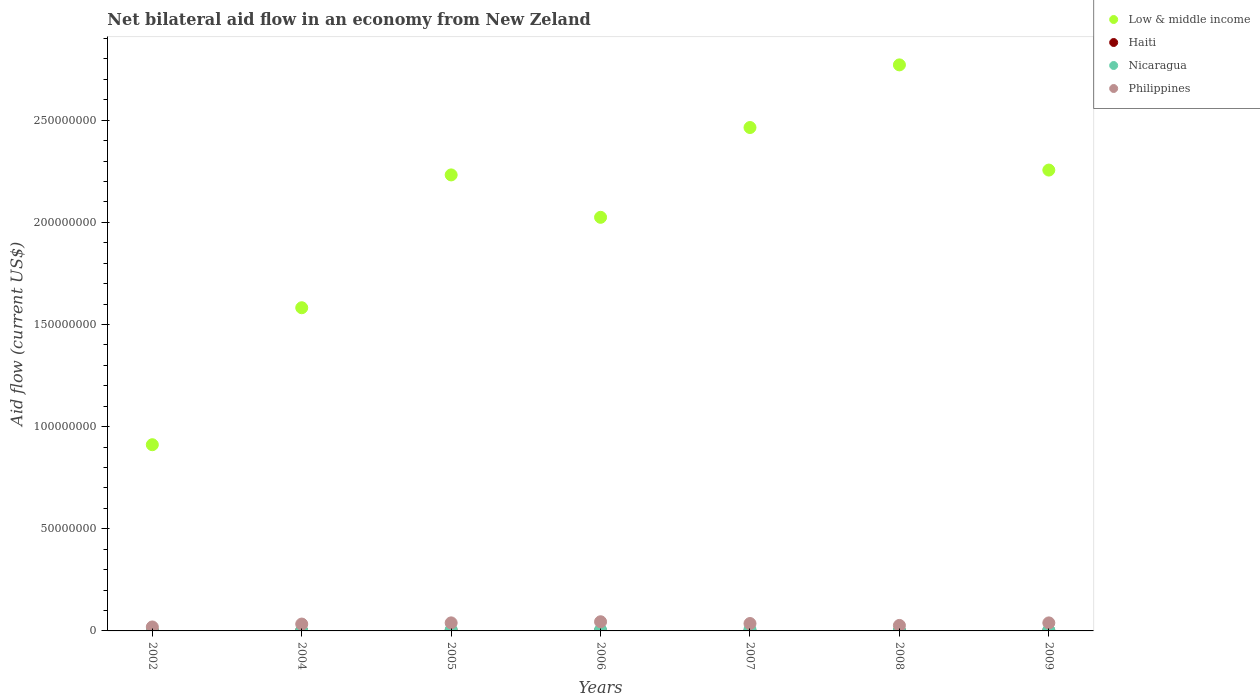Is the number of dotlines equal to the number of legend labels?
Ensure brevity in your answer.  Yes. What is the net bilateral aid flow in Philippines in 2007?
Offer a very short reply. 3.62e+06. Across all years, what is the minimum net bilateral aid flow in Low & middle income?
Give a very brief answer. 9.12e+07. What is the total net bilateral aid flow in Low & middle income in the graph?
Provide a short and direct response. 1.42e+09. What is the difference between the net bilateral aid flow in Haiti in 2004 and that in 2007?
Your response must be concise. 5.00e+04. What is the difference between the net bilateral aid flow in Nicaragua in 2004 and the net bilateral aid flow in Haiti in 2009?
Offer a terse response. 1.10e+05. What is the average net bilateral aid flow in Haiti per year?
Keep it short and to the point. 6.00e+04. In the year 2005, what is the difference between the net bilateral aid flow in Nicaragua and net bilateral aid flow in Low & middle income?
Ensure brevity in your answer.  -2.23e+08. In how many years, is the net bilateral aid flow in Haiti greater than 180000000 US$?
Your answer should be very brief. 0. What is the ratio of the net bilateral aid flow in Nicaragua in 2004 to that in 2007?
Give a very brief answer. 0.24. Is the net bilateral aid flow in Philippines in 2002 less than that in 2008?
Give a very brief answer. Yes. What is the difference between the highest and the second highest net bilateral aid flow in Philippines?
Your answer should be very brief. 5.50e+05. Is the sum of the net bilateral aid flow in Low & middle income in 2005 and 2007 greater than the maximum net bilateral aid flow in Philippines across all years?
Offer a terse response. Yes. Is it the case that in every year, the sum of the net bilateral aid flow in Low & middle income and net bilateral aid flow in Nicaragua  is greater than the sum of net bilateral aid flow in Haiti and net bilateral aid flow in Philippines?
Ensure brevity in your answer.  No. How many dotlines are there?
Your answer should be compact. 4. How many years are there in the graph?
Your answer should be compact. 7. What is the title of the graph?
Make the answer very short. Net bilateral aid flow in an economy from New Zeland. What is the Aid flow (current US$) in Low & middle income in 2002?
Provide a succinct answer. 9.12e+07. What is the Aid flow (current US$) of Philippines in 2002?
Your answer should be very brief. 1.94e+06. What is the Aid flow (current US$) of Low & middle income in 2004?
Provide a short and direct response. 1.58e+08. What is the Aid flow (current US$) of Haiti in 2004?
Your response must be concise. 7.00e+04. What is the Aid flow (current US$) in Philippines in 2004?
Offer a very short reply. 3.36e+06. What is the Aid flow (current US$) of Low & middle income in 2005?
Make the answer very short. 2.23e+08. What is the Aid flow (current US$) in Haiti in 2005?
Offer a terse response. 1.30e+05. What is the Aid flow (current US$) in Nicaragua in 2005?
Give a very brief answer. 5.80e+05. What is the Aid flow (current US$) of Philippines in 2005?
Give a very brief answer. 3.94e+06. What is the Aid flow (current US$) in Low & middle income in 2006?
Offer a very short reply. 2.02e+08. What is the Aid flow (current US$) of Haiti in 2006?
Provide a short and direct response. 7.00e+04. What is the Aid flow (current US$) in Nicaragua in 2006?
Offer a very short reply. 5.00e+05. What is the Aid flow (current US$) of Philippines in 2006?
Offer a very short reply. 4.49e+06. What is the Aid flow (current US$) of Low & middle income in 2007?
Provide a short and direct response. 2.46e+08. What is the Aid flow (current US$) of Haiti in 2007?
Keep it short and to the point. 2.00e+04. What is the Aid flow (current US$) in Philippines in 2007?
Offer a terse response. 3.62e+06. What is the Aid flow (current US$) in Low & middle income in 2008?
Provide a succinct answer. 2.77e+08. What is the Aid flow (current US$) in Haiti in 2008?
Provide a succinct answer. 6.00e+04. What is the Aid flow (current US$) in Nicaragua in 2008?
Offer a very short reply. 3.20e+05. What is the Aid flow (current US$) in Philippines in 2008?
Your answer should be very brief. 2.69e+06. What is the Aid flow (current US$) in Low & middle income in 2009?
Offer a terse response. 2.26e+08. What is the Aid flow (current US$) in Nicaragua in 2009?
Keep it short and to the point. 4.00e+05. What is the Aid flow (current US$) of Philippines in 2009?
Provide a short and direct response. 3.93e+06. Across all years, what is the maximum Aid flow (current US$) in Low & middle income?
Make the answer very short. 2.77e+08. Across all years, what is the maximum Aid flow (current US$) in Philippines?
Provide a succinct answer. 4.49e+06. Across all years, what is the minimum Aid flow (current US$) of Low & middle income?
Keep it short and to the point. 9.12e+07. Across all years, what is the minimum Aid flow (current US$) of Nicaragua?
Make the answer very short. 1.00e+05. Across all years, what is the minimum Aid flow (current US$) of Philippines?
Make the answer very short. 1.94e+06. What is the total Aid flow (current US$) in Low & middle income in the graph?
Provide a succinct answer. 1.42e+09. What is the total Aid flow (current US$) of Haiti in the graph?
Offer a terse response. 4.20e+05. What is the total Aid flow (current US$) of Nicaragua in the graph?
Your answer should be compact. 2.77e+06. What is the total Aid flow (current US$) in Philippines in the graph?
Keep it short and to the point. 2.40e+07. What is the difference between the Aid flow (current US$) in Low & middle income in 2002 and that in 2004?
Provide a short and direct response. -6.71e+07. What is the difference between the Aid flow (current US$) of Philippines in 2002 and that in 2004?
Offer a terse response. -1.42e+06. What is the difference between the Aid flow (current US$) in Low & middle income in 2002 and that in 2005?
Provide a succinct answer. -1.32e+08. What is the difference between the Aid flow (current US$) of Nicaragua in 2002 and that in 2005?
Your response must be concise. -4.80e+05. What is the difference between the Aid flow (current US$) in Low & middle income in 2002 and that in 2006?
Provide a succinct answer. -1.11e+08. What is the difference between the Aid flow (current US$) in Haiti in 2002 and that in 2006?
Offer a terse response. -6.00e+04. What is the difference between the Aid flow (current US$) in Nicaragua in 2002 and that in 2006?
Your response must be concise. -4.00e+05. What is the difference between the Aid flow (current US$) in Philippines in 2002 and that in 2006?
Make the answer very short. -2.55e+06. What is the difference between the Aid flow (current US$) in Low & middle income in 2002 and that in 2007?
Offer a very short reply. -1.55e+08. What is the difference between the Aid flow (current US$) of Haiti in 2002 and that in 2007?
Offer a very short reply. -10000. What is the difference between the Aid flow (current US$) in Nicaragua in 2002 and that in 2007?
Provide a succinct answer. -6.00e+05. What is the difference between the Aid flow (current US$) of Philippines in 2002 and that in 2007?
Give a very brief answer. -1.68e+06. What is the difference between the Aid flow (current US$) in Low & middle income in 2002 and that in 2008?
Make the answer very short. -1.86e+08. What is the difference between the Aid flow (current US$) of Nicaragua in 2002 and that in 2008?
Make the answer very short. -2.20e+05. What is the difference between the Aid flow (current US$) of Philippines in 2002 and that in 2008?
Your answer should be compact. -7.50e+05. What is the difference between the Aid flow (current US$) of Low & middle income in 2002 and that in 2009?
Ensure brevity in your answer.  -1.34e+08. What is the difference between the Aid flow (current US$) of Haiti in 2002 and that in 2009?
Your answer should be very brief. -5.00e+04. What is the difference between the Aid flow (current US$) of Philippines in 2002 and that in 2009?
Offer a very short reply. -1.99e+06. What is the difference between the Aid flow (current US$) in Low & middle income in 2004 and that in 2005?
Provide a short and direct response. -6.50e+07. What is the difference between the Aid flow (current US$) in Haiti in 2004 and that in 2005?
Your answer should be compact. -6.00e+04. What is the difference between the Aid flow (current US$) in Nicaragua in 2004 and that in 2005?
Provide a succinct answer. -4.10e+05. What is the difference between the Aid flow (current US$) in Philippines in 2004 and that in 2005?
Offer a terse response. -5.80e+05. What is the difference between the Aid flow (current US$) of Low & middle income in 2004 and that in 2006?
Give a very brief answer. -4.43e+07. What is the difference between the Aid flow (current US$) of Nicaragua in 2004 and that in 2006?
Offer a very short reply. -3.30e+05. What is the difference between the Aid flow (current US$) in Philippines in 2004 and that in 2006?
Provide a succinct answer. -1.13e+06. What is the difference between the Aid flow (current US$) of Low & middle income in 2004 and that in 2007?
Make the answer very short. -8.82e+07. What is the difference between the Aid flow (current US$) of Nicaragua in 2004 and that in 2007?
Make the answer very short. -5.30e+05. What is the difference between the Aid flow (current US$) of Low & middle income in 2004 and that in 2008?
Provide a succinct answer. -1.19e+08. What is the difference between the Aid flow (current US$) in Haiti in 2004 and that in 2008?
Your answer should be compact. 10000. What is the difference between the Aid flow (current US$) of Philippines in 2004 and that in 2008?
Provide a succinct answer. 6.70e+05. What is the difference between the Aid flow (current US$) of Low & middle income in 2004 and that in 2009?
Provide a succinct answer. -6.74e+07. What is the difference between the Aid flow (current US$) of Nicaragua in 2004 and that in 2009?
Make the answer very short. -2.30e+05. What is the difference between the Aid flow (current US$) of Philippines in 2004 and that in 2009?
Give a very brief answer. -5.70e+05. What is the difference between the Aid flow (current US$) in Low & middle income in 2005 and that in 2006?
Provide a short and direct response. 2.08e+07. What is the difference between the Aid flow (current US$) of Haiti in 2005 and that in 2006?
Make the answer very short. 6.00e+04. What is the difference between the Aid flow (current US$) in Philippines in 2005 and that in 2006?
Keep it short and to the point. -5.50e+05. What is the difference between the Aid flow (current US$) in Low & middle income in 2005 and that in 2007?
Your answer should be compact. -2.32e+07. What is the difference between the Aid flow (current US$) of Haiti in 2005 and that in 2007?
Your answer should be compact. 1.10e+05. What is the difference between the Aid flow (current US$) in Low & middle income in 2005 and that in 2008?
Ensure brevity in your answer.  -5.39e+07. What is the difference between the Aid flow (current US$) of Haiti in 2005 and that in 2008?
Provide a succinct answer. 7.00e+04. What is the difference between the Aid flow (current US$) in Philippines in 2005 and that in 2008?
Ensure brevity in your answer.  1.25e+06. What is the difference between the Aid flow (current US$) of Low & middle income in 2005 and that in 2009?
Provide a succinct answer. -2.37e+06. What is the difference between the Aid flow (current US$) in Nicaragua in 2005 and that in 2009?
Keep it short and to the point. 1.80e+05. What is the difference between the Aid flow (current US$) in Low & middle income in 2006 and that in 2007?
Provide a succinct answer. -4.40e+07. What is the difference between the Aid flow (current US$) of Haiti in 2006 and that in 2007?
Provide a succinct answer. 5.00e+04. What is the difference between the Aid flow (current US$) in Philippines in 2006 and that in 2007?
Provide a succinct answer. 8.70e+05. What is the difference between the Aid flow (current US$) in Low & middle income in 2006 and that in 2008?
Keep it short and to the point. -7.46e+07. What is the difference between the Aid flow (current US$) of Nicaragua in 2006 and that in 2008?
Ensure brevity in your answer.  1.80e+05. What is the difference between the Aid flow (current US$) in Philippines in 2006 and that in 2008?
Your answer should be very brief. 1.80e+06. What is the difference between the Aid flow (current US$) in Low & middle income in 2006 and that in 2009?
Make the answer very short. -2.31e+07. What is the difference between the Aid flow (current US$) of Haiti in 2006 and that in 2009?
Your answer should be compact. 10000. What is the difference between the Aid flow (current US$) in Philippines in 2006 and that in 2009?
Make the answer very short. 5.60e+05. What is the difference between the Aid flow (current US$) in Low & middle income in 2007 and that in 2008?
Ensure brevity in your answer.  -3.07e+07. What is the difference between the Aid flow (current US$) of Haiti in 2007 and that in 2008?
Make the answer very short. -4.00e+04. What is the difference between the Aid flow (current US$) of Philippines in 2007 and that in 2008?
Offer a terse response. 9.30e+05. What is the difference between the Aid flow (current US$) of Low & middle income in 2007 and that in 2009?
Make the answer very short. 2.08e+07. What is the difference between the Aid flow (current US$) in Philippines in 2007 and that in 2009?
Your answer should be compact. -3.10e+05. What is the difference between the Aid flow (current US$) in Low & middle income in 2008 and that in 2009?
Offer a terse response. 5.15e+07. What is the difference between the Aid flow (current US$) of Nicaragua in 2008 and that in 2009?
Offer a terse response. -8.00e+04. What is the difference between the Aid flow (current US$) of Philippines in 2008 and that in 2009?
Provide a succinct answer. -1.24e+06. What is the difference between the Aid flow (current US$) of Low & middle income in 2002 and the Aid flow (current US$) of Haiti in 2004?
Give a very brief answer. 9.11e+07. What is the difference between the Aid flow (current US$) in Low & middle income in 2002 and the Aid flow (current US$) in Nicaragua in 2004?
Offer a very short reply. 9.10e+07. What is the difference between the Aid flow (current US$) in Low & middle income in 2002 and the Aid flow (current US$) in Philippines in 2004?
Ensure brevity in your answer.  8.78e+07. What is the difference between the Aid flow (current US$) of Haiti in 2002 and the Aid flow (current US$) of Nicaragua in 2004?
Your response must be concise. -1.60e+05. What is the difference between the Aid flow (current US$) in Haiti in 2002 and the Aid flow (current US$) in Philippines in 2004?
Keep it short and to the point. -3.35e+06. What is the difference between the Aid flow (current US$) in Nicaragua in 2002 and the Aid flow (current US$) in Philippines in 2004?
Give a very brief answer. -3.26e+06. What is the difference between the Aid flow (current US$) in Low & middle income in 2002 and the Aid flow (current US$) in Haiti in 2005?
Provide a succinct answer. 9.10e+07. What is the difference between the Aid flow (current US$) in Low & middle income in 2002 and the Aid flow (current US$) in Nicaragua in 2005?
Offer a very short reply. 9.06e+07. What is the difference between the Aid flow (current US$) in Low & middle income in 2002 and the Aid flow (current US$) in Philippines in 2005?
Provide a succinct answer. 8.72e+07. What is the difference between the Aid flow (current US$) of Haiti in 2002 and the Aid flow (current US$) of Nicaragua in 2005?
Offer a very short reply. -5.70e+05. What is the difference between the Aid flow (current US$) of Haiti in 2002 and the Aid flow (current US$) of Philippines in 2005?
Make the answer very short. -3.93e+06. What is the difference between the Aid flow (current US$) in Nicaragua in 2002 and the Aid flow (current US$) in Philippines in 2005?
Ensure brevity in your answer.  -3.84e+06. What is the difference between the Aid flow (current US$) in Low & middle income in 2002 and the Aid flow (current US$) in Haiti in 2006?
Your answer should be compact. 9.11e+07. What is the difference between the Aid flow (current US$) of Low & middle income in 2002 and the Aid flow (current US$) of Nicaragua in 2006?
Give a very brief answer. 9.07e+07. What is the difference between the Aid flow (current US$) of Low & middle income in 2002 and the Aid flow (current US$) of Philippines in 2006?
Your answer should be compact. 8.67e+07. What is the difference between the Aid flow (current US$) in Haiti in 2002 and the Aid flow (current US$) in Nicaragua in 2006?
Your response must be concise. -4.90e+05. What is the difference between the Aid flow (current US$) of Haiti in 2002 and the Aid flow (current US$) of Philippines in 2006?
Offer a very short reply. -4.48e+06. What is the difference between the Aid flow (current US$) of Nicaragua in 2002 and the Aid flow (current US$) of Philippines in 2006?
Make the answer very short. -4.39e+06. What is the difference between the Aid flow (current US$) in Low & middle income in 2002 and the Aid flow (current US$) in Haiti in 2007?
Ensure brevity in your answer.  9.11e+07. What is the difference between the Aid flow (current US$) in Low & middle income in 2002 and the Aid flow (current US$) in Nicaragua in 2007?
Offer a terse response. 9.05e+07. What is the difference between the Aid flow (current US$) in Low & middle income in 2002 and the Aid flow (current US$) in Philippines in 2007?
Give a very brief answer. 8.75e+07. What is the difference between the Aid flow (current US$) in Haiti in 2002 and the Aid flow (current US$) in Nicaragua in 2007?
Your response must be concise. -6.90e+05. What is the difference between the Aid flow (current US$) of Haiti in 2002 and the Aid flow (current US$) of Philippines in 2007?
Offer a terse response. -3.61e+06. What is the difference between the Aid flow (current US$) of Nicaragua in 2002 and the Aid flow (current US$) of Philippines in 2007?
Provide a succinct answer. -3.52e+06. What is the difference between the Aid flow (current US$) in Low & middle income in 2002 and the Aid flow (current US$) in Haiti in 2008?
Give a very brief answer. 9.11e+07. What is the difference between the Aid flow (current US$) in Low & middle income in 2002 and the Aid flow (current US$) in Nicaragua in 2008?
Ensure brevity in your answer.  9.08e+07. What is the difference between the Aid flow (current US$) of Low & middle income in 2002 and the Aid flow (current US$) of Philippines in 2008?
Your answer should be compact. 8.85e+07. What is the difference between the Aid flow (current US$) of Haiti in 2002 and the Aid flow (current US$) of Nicaragua in 2008?
Your response must be concise. -3.10e+05. What is the difference between the Aid flow (current US$) in Haiti in 2002 and the Aid flow (current US$) in Philippines in 2008?
Ensure brevity in your answer.  -2.68e+06. What is the difference between the Aid flow (current US$) in Nicaragua in 2002 and the Aid flow (current US$) in Philippines in 2008?
Your answer should be compact. -2.59e+06. What is the difference between the Aid flow (current US$) in Low & middle income in 2002 and the Aid flow (current US$) in Haiti in 2009?
Make the answer very short. 9.11e+07. What is the difference between the Aid flow (current US$) in Low & middle income in 2002 and the Aid flow (current US$) in Nicaragua in 2009?
Your response must be concise. 9.08e+07. What is the difference between the Aid flow (current US$) of Low & middle income in 2002 and the Aid flow (current US$) of Philippines in 2009?
Offer a very short reply. 8.72e+07. What is the difference between the Aid flow (current US$) of Haiti in 2002 and the Aid flow (current US$) of Nicaragua in 2009?
Your answer should be compact. -3.90e+05. What is the difference between the Aid flow (current US$) of Haiti in 2002 and the Aid flow (current US$) of Philippines in 2009?
Offer a very short reply. -3.92e+06. What is the difference between the Aid flow (current US$) in Nicaragua in 2002 and the Aid flow (current US$) in Philippines in 2009?
Provide a short and direct response. -3.83e+06. What is the difference between the Aid flow (current US$) in Low & middle income in 2004 and the Aid flow (current US$) in Haiti in 2005?
Keep it short and to the point. 1.58e+08. What is the difference between the Aid flow (current US$) of Low & middle income in 2004 and the Aid flow (current US$) of Nicaragua in 2005?
Ensure brevity in your answer.  1.58e+08. What is the difference between the Aid flow (current US$) of Low & middle income in 2004 and the Aid flow (current US$) of Philippines in 2005?
Offer a very short reply. 1.54e+08. What is the difference between the Aid flow (current US$) of Haiti in 2004 and the Aid flow (current US$) of Nicaragua in 2005?
Your response must be concise. -5.10e+05. What is the difference between the Aid flow (current US$) in Haiti in 2004 and the Aid flow (current US$) in Philippines in 2005?
Your answer should be compact. -3.87e+06. What is the difference between the Aid flow (current US$) of Nicaragua in 2004 and the Aid flow (current US$) of Philippines in 2005?
Make the answer very short. -3.77e+06. What is the difference between the Aid flow (current US$) of Low & middle income in 2004 and the Aid flow (current US$) of Haiti in 2006?
Make the answer very short. 1.58e+08. What is the difference between the Aid flow (current US$) of Low & middle income in 2004 and the Aid flow (current US$) of Nicaragua in 2006?
Ensure brevity in your answer.  1.58e+08. What is the difference between the Aid flow (current US$) of Low & middle income in 2004 and the Aid flow (current US$) of Philippines in 2006?
Your response must be concise. 1.54e+08. What is the difference between the Aid flow (current US$) in Haiti in 2004 and the Aid flow (current US$) in Nicaragua in 2006?
Keep it short and to the point. -4.30e+05. What is the difference between the Aid flow (current US$) in Haiti in 2004 and the Aid flow (current US$) in Philippines in 2006?
Offer a terse response. -4.42e+06. What is the difference between the Aid flow (current US$) in Nicaragua in 2004 and the Aid flow (current US$) in Philippines in 2006?
Make the answer very short. -4.32e+06. What is the difference between the Aid flow (current US$) in Low & middle income in 2004 and the Aid flow (current US$) in Haiti in 2007?
Your response must be concise. 1.58e+08. What is the difference between the Aid flow (current US$) in Low & middle income in 2004 and the Aid flow (current US$) in Nicaragua in 2007?
Provide a succinct answer. 1.58e+08. What is the difference between the Aid flow (current US$) in Low & middle income in 2004 and the Aid flow (current US$) in Philippines in 2007?
Provide a succinct answer. 1.55e+08. What is the difference between the Aid flow (current US$) in Haiti in 2004 and the Aid flow (current US$) in Nicaragua in 2007?
Offer a terse response. -6.30e+05. What is the difference between the Aid flow (current US$) of Haiti in 2004 and the Aid flow (current US$) of Philippines in 2007?
Keep it short and to the point. -3.55e+06. What is the difference between the Aid flow (current US$) of Nicaragua in 2004 and the Aid flow (current US$) of Philippines in 2007?
Keep it short and to the point. -3.45e+06. What is the difference between the Aid flow (current US$) of Low & middle income in 2004 and the Aid flow (current US$) of Haiti in 2008?
Offer a terse response. 1.58e+08. What is the difference between the Aid flow (current US$) in Low & middle income in 2004 and the Aid flow (current US$) in Nicaragua in 2008?
Keep it short and to the point. 1.58e+08. What is the difference between the Aid flow (current US$) of Low & middle income in 2004 and the Aid flow (current US$) of Philippines in 2008?
Give a very brief answer. 1.56e+08. What is the difference between the Aid flow (current US$) of Haiti in 2004 and the Aid flow (current US$) of Nicaragua in 2008?
Your answer should be very brief. -2.50e+05. What is the difference between the Aid flow (current US$) of Haiti in 2004 and the Aid flow (current US$) of Philippines in 2008?
Your answer should be compact. -2.62e+06. What is the difference between the Aid flow (current US$) of Nicaragua in 2004 and the Aid flow (current US$) of Philippines in 2008?
Your answer should be very brief. -2.52e+06. What is the difference between the Aid flow (current US$) in Low & middle income in 2004 and the Aid flow (current US$) in Haiti in 2009?
Your response must be concise. 1.58e+08. What is the difference between the Aid flow (current US$) of Low & middle income in 2004 and the Aid flow (current US$) of Nicaragua in 2009?
Provide a short and direct response. 1.58e+08. What is the difference between the Aid flow (current US$) in Low & middle income in 2004 and the Aid flow (current US$) in Philippines in 2009?
Keep it short and to the point. 1.54e+08. What is the difference between the Aid flow (current US$) of Haiti in 2004 and the Aid flow (current US$) of Nicaragua in 2009?
Make the answer very short. -3.30e+05. What is the difference between the Aid flow (current US$) in Haiti in 2004 and the Aid flow (current US$) in Philippines in 2009?
Give a very brief answer. -3.86e+06. What is the difference between the Aid flow (current US$) in Nicaragua in 2004 and the Aid flow (current US$) in Philippines in 2009?
Offer a very short reply. -3.76e+06. What is the difference between the Aid flow (current US$) in Low & middle income in 2005 and the Aid flow (current US$) in Haiti in 2006?
Provide a succinct answer. 2.23e+08. What is the difference between the Aid flow (current US$) in Low & middle income in 2005 and the Aid flow (current US$) in Nicaragua in 2006?
Make the answer very short. 2.23e+08. What is the difference between the Aid flow (current US$) of Low & middle income in 2005 and the Aid flow (current US$) of Philippines in 2006?
Keep it short and to the point. 2.19e+08. What is the difference between the Aid flow (current US$) of Haiti in 2005 and the Aid flow (current US$) of Nicaragua in 2006?
Provide a succinct answer. -3.70e+05. What is the difference between the Aid flow (current US$) of Haiti in 2005 and the Aid flow (current US$) of Philippines in 2006?
Make the answer very short. -4.36e+06. What is the difference between the Aid flow (current US$) in Nicaragua in 2005 and the Aid flow (current US$) in Philippines in 2006?
Give a very brief answer. -3.91e+06. What is the difference between the Aid flow (current US$) in Low & middle income in 2005 and the Aid flow (current US$) in Haiti in 2007?
Offer a terse response. 2.23e+08. What is the difference between the Aid flow (current US$) in Low & middle income in 2005 and the Aid flow (current US$) in Nicaragua in 2007?
Keep it short and to the point. 2.23e+08. What is the difference between the Aid flow (current US$) in Low & middle income in 2005 and the Aid flow (current US$) in Philippines in 2007?
Your answer should be very brief. 2.20e+08. What is the difference between the Aid flow (current US$) in Haiti in 2005 and the Aid flow (current US$) in Nicaragua in 2007?
Your answer should be very brief. -5.70e+05. What is the difference between the Aid flow (current US$) of Haiti in 2005 and the Aid flow (current US$) of Philippines in 2007?
Provide a short and direct response. -3.49e+06. What is the difference between the Aid flow (current US$) of Nicaragua in 2005 and the Aid flow (current US$) of Philippines in 2007?
Keep it short and to the point. -3.04e+06. What is the difference between the Aid flow (current US$) of Low & middle income in 2005 and the Aid flow (current US$) of Haiti in 2008?
Ensure brevity in your answer.  2.23e+08. What is the difference between the Aid flow (current US$) of Low & middle income in 2005 and the Aid flow (current US$) of Nicaragua in 2008?
Ensure brevity in your answer.  2.23e+08. What is the difference between the Aid flow (current US$) in Low & middle income in 2005 and the Aid flow (current US$) in Philippines in 2008?
Offer a terse response. 2.21e+08. What is the difference between the Aid flow (current US$) of Haiti in 2005 and the Aid flow (current US$) of Nicaragua in 2008?
Give a very brief answer. -1.90e+05. What is the difference between the Aid flow (current US$) in Haiti in 2005 and the Aid flow (current US$) in Philippines in 2008?
Your answer should be compact. -2.56e+06. What is the difference between the Aid flow (current US$) in Nicaragua in 2005 and the Aid flow (current US$) in Philippines in 2008?
Provide a succinct answer. -2.11e+06. What is the difference between the Aid flow (current US$) in Low & middle income in 2005 and the Aid flow (current US$) in Haiti in 2009?
Offer a very short reply. 2.23e+08. What is the difference between the Aid flow (current US$) in Low & middle income in 2005 and the Aid flow (current US$) in Nicaragua in 2009?
Your response must be concise. 2.23e+08. What is the difference between the Aid flow (current US$) in Low & middle income in 2005 and the Aid flow (current US$) in Philippines in 2009?
Your response must be concise. 2.19e+08. What is the difference between the Aid flow (current US$) of Haiti in 2005 and the Aid flow (current US$) of Philippines in 2009?
Your answer should be compact. -3.80e+06. What is the difference between the Aid flow (current US$) of Nicaragua in 2005 and the Aid flow (current US$) of Philippines in 2009?
Your answer should be compact. -3.35e+06. What is the difference between the Aid flow (current US$) of Low & middle income in 2006 and the Aid flow (current US$) of Haiti in 2007?
Keep it short and to the point. 2.02e+08. What is the difference between the Aid flow (current US$) of Low & middle income in 2006 and the Aid flow (current US$) of Nicaragua in 2007?
Your answer should be very brief. 2.02e+08. What is the difference between the Aid flow (current US$) in Low & middle income in 2006 and the Aid flow (current US$) in Philippines in 2007?
Make the answer very short. 1.99e+08. What is the difference between the Aid flow (current US$) of Haiti in 2006 and the Aid flow (current US$) of Nicaragua in 2007?
Your answer should be very brief. -6.30e+05. What is the difference between the Aid flow (current US$) in Haiti in 2006 and the Aid flow (current US$) in Philippines in 2007?
Offer a terse response. -3.55e+06. What is the difference between the Aid flow (current US$) in Nicaragua in 2006 and the Aid flow (current US$) in Philippines in 2007?
Ensure brevity in your answer.  -3.12e+06. What is the difference between the Aid flow (current US$) of Low & middle income in 2006 and the Aid flow (current US$) of Haiti in 2008?
Keep it short and to the point. 2.02e+08. What is the difference between the Aid flow (current US$) in Low & middle income in 2006 and the Aid flow (current US$) in Nicaragua in 2008?
Your answer should be compact. 2.02e+08. What is the difference between the Aid flow (current US$) in Low & middle income in 2006 and the Aid flow (current US$) in Philippines in 2008?
Your response must be concise. 2.00e+08. What is the difference between the Aid flow (current US$) of Haiti in 2006 and the Aid flow (current US$) of Nicaragua in 2008?
Ensure brevity in your answer.  -2.50e+05. What is the difference between the Aid flow (current US$) of Haiti in 2006 and the Aid flow (current US$) of Philippines in 2008?
Give a very brief answer. -2.62e+06. What is the difference between the Aid flow (current US$) in Nicaragua in 2006 and the Aid flow (current US$) in Philippines in 2008?
Your answer should be compact. -2.19e+06. What is the difference between the Aid flow (current US$) in Low & middle income in 2006 and the Aid flow (current US$) in Haiti in 2009?
Your answer should be compact. 2.02e+08. What is the difference between the Aid flow (current US$) of Low & middle income in 2006 and the Aid flow (current US$) of Nicaragua in 2009?
Give a very brief answer. 2.02e+08. What is the difference between the Aid flow (current US$) in Low & middle income in 2006 and the Aid flow (current US$) in Philippines in 2009?
Give a very brief answer. 1.99e+08. What is the difference between the Aid flow (current US$) in Haiti in 2006 and the Aid flow (current US$) in Nicaragua in 2009?
Give a very brief answer. -3.30e+05. What is the difference between the Aid flow (current US$) of Haiti in 2006 and the Aid flow (current US$) of Philippines in 2009?
Your answer should be very brief. -3.86e+06. What is the difference between the Aid flow (current US$) of Nicaragua in 2006 and the Aid flow (current US$) of Philippines in 2009?
Provide a succinct answer. -3.43e+06. What is the difference between the Aid flow (current US$) in Low & middle income in 2007 and the Aid flow (current US$) in Haiti in 2008?
Offer a terse response. 2.46e+08. What is the difference between the Aid flow (current US$) in Low & middle income in 2007 and the Aid flow (current US$) in Nicaragua in 2008?
Your response must be concise. 2.46e+08. What is the difference between the Aid flow (current US$) in Low & middle income in 2007 and the Aid flow (current US$) in Philippines in 2008?
Ensure brevity in your answer.  2.44e+08. What is the difference between the Aid flow (current US$) of Haiti in 2007 and the Aid flow (current US$) of Nicaragua in 2008?
Give a very brief answer. -3.00e+05. What is the difference between the Aid flow (current US$) in Haiti in 2007 and the Aid flow (current US$) in Philippines in 2008?
Your answer should be very brief. -2.67e+06. What is the difference between the Aid flow (current US$) in Nicaragua in 2007 and the Aid flow (current US$) in Philippines in 2008?
Ensure brevity in your answer.  -1.99e+06. What is the difference between the Aid flow (current US$) in Low & middle income in 2007 and the Aid flow (current US$) in Haiti in 2009?
Your answer should be very brief. 2.46e+08. What is the difference between the Aid flow (current US$) in Low & middle income in 2007 and the Aid flow (current US$) in Nicaragua in 2009?
Make the answer very short. 2.46e+08. What is the difference between the Aid flow (current US$) of Low & middle income in 2007 and the Aid flow (current US$) of Philippines in 2009?
Offer a terse response. 2.43e+08. What is the difference between the Aid flow (current US$) in Haiti in 2007 and the Aid flow (current US$) in Nicaragua in 2009?
Your answer should be compact. -3.80e+05. What is the difference between the Aid flow (current US$) in Haiti in 2007 and the Aid flow (current US$) in Philippines in 2009?
Offer a terse response. -3.91e+06. What is the difference between the Aid flow (current US$) of Nicaragua in 2007 and the Aid flow (current US$) of Philippines in 2009?
Provide a succinct answer. -3.23e+06. What is the difference between the Aid flow (current US$) in Low & middle income in 2008 and the Aid flow (current US$) in Haiti in 2009?
Your answer should be very brief. 2.77e+08. What is the difference between the Aid flow (current US$) in Low & middle income in 2008 and the Aid flow (current US$) in Nicaragua in 2009?
Your answer should be very brief. 2.77e+08. What is the difference between the Aid flow (current US$) in Low & middle income in 2008 and the Aid flow (current US$) in Philippines in 2009?
Ensure brevity in your answer.  2.73e+08. What is the difference between the Aid flow (current US$) of Haiti in 2008 and the Aid flow (current US$) of Nicaragua in 2009?
Your response must be concise. -3.40e+05. What is the difference between the Aid flow (current US$) in Haiti in 2008 and the Aid flow (current US$) in Philippines in 2009?
Ensure brevity in your answer.  -3.87e+06. What is the difference between the Aid flow (current US$) of Nicaragua in 2008 and the Aid flow (current US$) of Philippines in 2009?
Offer a terse response. -3.61e+06. What is the average Aid flow (current US$) in Low & middle income per year?
Your answer should be compact. 2.03e+08. What is the average Aid flow (current US$) of Nicaragua per year?
Keep it short and to the point. 3.96e+05. What is the average Aid flow (current US$) of Philippines per year?
Keep it short and to the point. 3.42e+06. In the year 2002, what is the difference between the Aid flow (current US$) of Low & middle income and Aid flow (current US$) of Haiti?
Keep it short and to the point. 9.12e+07. In the year 2002, what is the difference between the Aid flow (current US$) of Low & middle income and Aid flow (current US$) of Nicaragua?
Keep it short and to the point. 9.11e+07. In the year 2002, what is the difference between the Aid flow (current US$) of Low & middle income and Aid flow (current US$) of Philippines?
Your response must be concise. 8.92e+07. In the year 2002, what is the difference between the Aid flow (current US$) of Haiti and Aid flow (current US$) of Philippines?
Make the answer very short. -1.93e+06. In the year 2002, what is the difference between the Aid flow (current US$) in Nicaragua and Aid flow (current US$) in Philippines?
Offer a very short reply. -1.84e+06. In the year 2004, what is the difference between the Aid flow (current US$) in Low & middle income and Aid flow (current US$) in Haiti?
Ensure brevity in your answer.  1.58e+08. In the year 2004, what is the difference between the Aid flow (current US$) in Low & middle income and Aid flow (current US$) in Nicaragua?
Keep it short and to the point. 1.58e+08. In the year 2004, what is the difference between the Aid flow (current US$) of Low & middle income and Aid flow (current US$) of Philippines?
Provide a succinct answer. 1.55e+08. In the year 2004, what is the difference between the Aid flow (current US$) of Haiti and Aid flow (current US$) of Philippines?
Ensure brevity in your answer.  -3.29e+06. In the year 2004, what is the difference between the Aid flow (current US$) in Nicaragua and Aid flow (current US$) in Philippines?
Keep it short and to the point. -3.19e+06. In the year 2005, what is the difference between the Aid flow (current US$) of Low & middle income and Aid flow (current US$) of Haiti?
Keep it short and to the point. 2.23e+08. In the year 2005, what is the difference between the Aid flow (current US$) in Low & middle income and Aid flow (current US$) in Nicaragua?
Your answer should be compact. 2.23e+08. In the year 2005, what is the difference between the Aid flow (current US$) of Low & middle income and Aid flow (current US$) of Philippines?
Make the answer very short. 2.19e+08. In the year 2005, what is the difference between the Aid flow (current US$) in Haiti and Aid flow (current US$) in Nicaragua?
Your answer should be compact. -4.50e+05. In the year 2005, what is the difference between the Aid flow (current US$) in Haiti and Aid flow (current US$) in Philippines?
Offer a very short reply. -3.81e+06. In the year 2005, what is the difference between the Aid flow (current US$) of Nicaragua and Aid flow (current US$) of Philippines?
Provide a short and direct response. -3.36e+06. In the year 2006, what is the difference between the Aid flow (current US$) in Low & middle income and Aid flow (current US$) in Haiti?
Make the answer very short. 2.02e+08. In the year 2006, what is the difference between the Aid flow (current US$) in Low & middle income and Aid flow (current US$) in Nicaragua?
Make the answer very short. 2.02e+08. In the year 2006, what is the difference between the Aid flow (current US$) of Low & middle income and Aid flow (current US$) of Philippines?
Offer a terse response. 1.98e+08. In the year 2006, what is the difference between the Aid flow (current US$) in Haiti and Aid flow (current US$) in Nicaragua?
Keep it short and to the point. -4.30e+05. In the year 2006, what is the difference between the Aid flow (current US$) of Haiti and Aid flow (current US$) of Philippines?
Provide a succinct answer. -4.42e+06. In the year 2006, what is the difference between the Aid flow (current US$) in Nicaragua and Aid flow (current US$) in Philippines?
Your answer should be very brief. -3.99e+06. In the year 2007, what is the difference between the Aid flow (current US$) in Low & middle income and Aid flow (current US$) in Haiti?
Your response must be concise. 2.46e+08. In the year 2007, what is the difference between the Aid flow (current US$) in Low & middle income and Aid flow (current US$) in Nicaragua?
Offer a terse response. 2.46e+08. In the year 2007, what is the difference between the Aid flow (current US$) of Low & middle income and Aid flow (current US$) of Philippines?
Make the answer very short. 2.43e+08. In the year 2007, what is the difference between the Aid flow (current US$) in Haiti and Aid flow (current US$) in Nicaragua?
Make the answer very short. -6.80e+05. In the year 2007, what is the difference between the Aid flow (current US$) in Haiti and Aid flow (current US$) in Philippines?
Provide a short and direct response. -3.60e+06. In the year 2007, what is the difference between the Aid flow (current US$) in Nicaragua and Aid flow (current US$) in Philippines?
Provide a short and direct response. -2.92e+06. In the year 2008, what is the difference between the Aid flow (current US$) in Low & middle income and Aid flow (current US$) in Haiti?
Give a very brief answer. 2.77e+08. In the year 2008, what is the difference between the Aid flow (current US$) of Low & middle income and Aid flow (current US$) of Nicaragua?
Make the answer very short. 2.77e+08. In the year 2008, what is the difference between the Aid flow (current US$) in Low & middle income and Aid flow (current US$) in Philippines?
Your answer should be very brief. 2.74e+08. In the year 2008, what is the difference between the Aid flow (current US$) of Haiti and Aid flow (current US$) of Nicaragua?
Provide a succinct answer. -2.60e+05. In the year 2008, what is the difference between the Aid flow (current US$) of Haiti and Aid flow (current US$) of Philippines?
Make the answer very short. -2.63e+06. In the year 2008, what is the difference between the Aid flow (current US$) of Nicaragua and Aid flow (current US$) of Philippines?
Your answer should be compact. -2.37e+06. In the year 2009, what is the difference between the Aid flow (current US$) of Low & middle income and Aid flow (current US$) of Haiti?
Ensure brevity in your answer.  2.26e+08. In the year 2009, what is the difference between the Aid flow (current US$) in Low & middle income and Aid flow (current US$) in Nicaragua?
Offer a very short reply. 2.25e+08. In the year 2009, what is the difference between the Aid flow (current US$) in Low & middle income and Aid flow (current US$) in Philippines?
Offer a terse response. 2.22e+08. In the year 2009, what is the difference between the Aid flow (current US$) of Haiti and Aid flow (current US$) of Philippines?
Make the answer very short. -3.87e+06. In the year 2009, what is the difference between the Aid flow (current US$) of Nicaragua and Aid flow (current US$) of Philippines?
Your answer should be very brief. -3.53e+06. What is the ratio of the Aid flow (current US$) in Low & middle income in 2002 to that in 2004?
Your answer should be very brief. 0.58. What is the ratio of the Aid flow (current US$) of Haiti in 2002 to that in 2004?
Provide a short and direct response. 0.14. What is the ratio of the Aid flow (current US$) in Nicaragua in 2002 to that in 2004?
Offer a very short reply. 0.59. What is the ratio of the Aid flow (current US$) in Philippines in 2002 to that in 2004?
Your answer should be very brief. 0.58. What is the ratio of the Aid flow (current US$) in Low & middle income in 2002 to that in 2005?
Offer a terse response. 0.41. What is the ratio of the Aid flow (current US$) of Haiti in 2002 to that in 2005?
Offer a terse response. 0.08. What is the ratio of the Aid flow (current US$) in Nicaragua in 2002 to that in 2005?
Keep it short and to the point. 0.17. What is the ratio of the Aid flow (current US$) in Philippines in 2002 to that in 2005?
Your response must be concise. 0.49. What is the ratio of the Aid flow (current US$) in Low & middle income in 2002 to that in 2006?
Your answer should be compact. 0.45. What is the ratio of the Aid flow (current US$) in Haiti in 2002 to that in 2006?
Ensure brevity in your answer.  0.14. What is the ratio of the Aid flow (current US$) in Philippines in 2002 to that in 2006?
Offer a terse response. 0.43. What is the ratio of the Aid flow (current US$) in Low & middle income in 2002 to that in 2007?
Provide a short and direct response. 0.37. What is the ratio of the Aid flow (current US$) in Haiti in 2002 to that in 2007?
Provide a short and direct response. 0.5. What is the ratio of the Aid flow (current US$) in Nicaragua in 2002 to that in 2007?
Keep it short and to the point. 0.14. What is the ratio of the Aid flow (current US$) of Philippines in 2002 to that in 2007?
Keep it short and to the point. 0.54. What is the ratio of the Aid flow (current US$) of Low & middle income in 2002 to that in 2008?
Give a very brief answer. 0.33. What is the ratio of the Aid flow (current US$) of Haiti in 2002 to that in 2008?
Ensure brevity in your answer.  0.17. What is the ratio of the Aid flow (current US$) of Nicaragua in 2002 to that in 2008?
Your response must be concise. 0.31. What is the ratio of the Aid flow (current US$) of Philippines in 2002 to that in 2008?
Offer a very short reply. 0.72. What is the ratio of the Aid flow (current US$) of Low & middle income in 2002 to that in 2009?
Your answer should be compact. 0.4. What is the ratio of the Aid flow (current US$) in Nicaragua in 2002 to that in 2009?
Provide a short and direct response. 0.25. What is the ratio of the Aid flow (current US$) of Philippines in 2002 to that in 2009?
Ensure brevity in your answer.  0.49. What is the ratio of the Aid flow (current US$) in Low & middle income in 2004 to that in 2005?
Give a very brief answer. 0.71. What is the ratio of the Aid flow (current US$) of Haiti in 2004 to that in 2005?
Keep it short and to the point. 0.54. What is the ratio of the Aid flow (current US$) of Nicaragua in 2004 to that in 2005?
Keep it short and to the point. 0.29. What is the ratio of the Aid flow (current US$) of Philippines in 2004 to that in 2005?
Your response must be concise. 0.85. What is the ratio of the Aid flow (current US$) in Low & middle income in 2004 to that in 2006?
Your response must be concise. 0.78. What is the ratio of the Aid flow (current US$) in Nicaragua in 2004 to that in 2006?
Your response must be concise. 0.34. What is the ratio of the Aid flow (current US$) in Philippines in 2004 to that in 2006?
Keep it short and to the point. 0.75. What is the ratio of the Aid flow (current US$) in Low & middle income in 2004 to that in 2007?
Keep it short and to the point. 0.64. What is the ratio of the Aid flow (current US$) in Haiti in 2004 to that in 2007?
Make the answer very short. 3.5. What is the ratio of the Aid flow (current US$) in Nicaragua in 2004 to that in 2007?
Ensure brevity in your answer.  0.24. What is the ratio of the Aid flow (current US$) in Philippines in 2004 to that in 2007?
Keep it short and to the point. 0.93. What is the ratio of the Aid flow (current US$) of Low & middle income in 2004 to that in 2008?
Your response must be concise. 0.57. What is the ratio of the Aid flow (current US$) in Nicaragua in 2004 to that in 2008?
Give a very brief answer. 0.53. What is the ratio of the Aid flow (current US$) in Philippines in 2004 to that in 2008?
Your response must be concise. 1.25. What is the ratio of the Aid flow (current US$) of Low & middle income in 2004 to that in 2009?
Give a very brief answer. 0.7. What is the ratio of the Aid flow (current US$) of Haiti in 2004 to that in 2009?
Provide a succinct answer. 1.17. What is the ratio of the Aid flow (current US$) in Nicaragua in 2004 to that in 2009?
Provide a short and direct response. 0.42. What is the ratio of the Aid flow (current US$) in Philippines in 2004 to that in 2009?
Your response must be concise. 0.85. What is the ratio of the Aid flow (current US$) in Low & middle income in 2005 to that in 2006?
Your response must be concise. 1.1. What is the ratio of the Aid flow (current US$) in Haiti in 2005 to that in 2006?
Keep it short and to the point. 1.86. What is the ratio of the Aid flow (current US$) in Nicaragua in 2005 to that in 2006?
Keep it short and to the point. 1.16. What is the ratio of the Aid flow (current US$) in Philippines in 2005 to that in 2006?
Offer a terse response. 0.88. What is the ratio of the Aid flow (current US$) of Low & middle income in 2005 to that in 2007?
Ensure brevity in your answer.  0.91. What is the ratio of the Aid flow (current US$) of Haiti in 2005 to that in 2007?
Give a very brief answer. 6.5. What is the ratio of the Aid flow (current US$) of Nicaragua in 2005 to that in 2007?
Offer a terse response. 0.83. What is the ratio of the Aid flow (current US$) in Philippines in 2005 to that in 2007?
Provide a short and direct response. 1.09. What is the ratio of the Aid flow (current US$) in Low & middle income in 2005 to that in 2008?
Provide a succinct answer. 0.81. What is the ratio of the Aid flow (current US$) of Haiti in 2005 to that in 2008?
Offer a terse response. 2.17. What is the ratio of the Aid flow (current US$) in Nicaragua in 2005 to that in 2008?
Offer a terse response. 1.81. What is the ratio of the Aid flow (current US$) of Philippines in 2005 to that in 2008?
Make the answer very short. 1.46. What is the ratio of the Aid flow (current US$) in Haiti in 2005 to that in 2009?
Give a very brief answer. 2.17. What is the ratio of the Aid flow (current US$) of Nicaragua in 2005 to that in 2009?
Give a very brief answer. 1.45. What is the ratio of the Aid flow (current US$) in Philippines in 2005 to that in 2009?
Your response must be concise. 1. What is the ratio of the Aid flow (current US$) in Low & middle income in 2006 to that in 2007?
Provide a short and direct response. 0.82. What is the ratio of the Aid flow (current US$) in Nicaragua in 2006 to that in 2007?
Provide a succinct answer. 0.71. What is the ratio of the Aid flow (current US$) in Philippines in 2006 to that in 2007?
Make the answer very short. 1.24. What is the ratio of the Aid flow (current US$) in Low & middle income in 2006 to that in 2008?
Ensure brevity in your answer.  0.73. What is the ratio of the Aid flow (current US$) of Nicaragua in 2006 to that in 2008?
Your response must be concise. 1.56. What is the ratio of the Aid flow (current US$) of Philippines in 2006 to that in 2008?
Give a very brief answer. 1.67. What is the ratio of the Aid flow (current US$) in Low & middle income in 2006 to that in 2009?
Offer a terse response. 0.9. What is the ratio of the Aid flow (current US$) in Nicaragua in 2006 to that in 2009?
Offer a very short reply. 1.25. What is the ratio of the Aid flow (current US$) of Philippines in 2006 to that in 2009?
Offer a terse response. 1.14. What is the ratio of the Aid flow (current US$) of Low & middle income in 2007 to that in 2008?
Your answer should be compact. 0.89. What is the ratio of the Aid flow (current US$) in Haiti in 2007 to that in 2008?
Provide a succinct answer. 0.33. What is the ratio of the Aid flow (current US$) in Nicaragua in 2007 to that in 2008?
Offer a terse response. 2.19. What is the ratio of the Aid flow (current US$) in Philippines in 2007 to that in 2008?
Offer a terse response. 1.35. What is the ratio of the Aid flow (current US$) of Low & middle income in 2007 to that in 2009?
Provide a succinct answer. 1.09. What is the ratio of the Aid flow (current US$) in Haiti in 2007 to that in 2009?
Provide a succinct answer. 0.33. What is the ratio of the Aid flow (current US$) of Philippines in 2007 to that in 2009?
Offer a very short reply. 0.92. What is the ratio of the Aid flow (current US$) in Low & middle income in 2008 to that in 2009?
Make the answer very short. 1.23. What is the ratio of the Aid flow (current US$) in Haiti in 2008 to that in 2009?
Offer a terse response. 1. What is the ratio of the Aid flow (current US$) in Philippines in 2008 to that in 2009?
Make the answer very short. 0.68. What is the difference between the highest and the second highest Aid flow (current US$) in Low & middle income?
Give a very brief answer. 3.07e+07. What is the difference between the highest and the lowest Aid flow (current US$) in Low & middle income?
Your response must be concise. 1.86e+08. What is the difference between the highest and the lowest Aid flow (current US$) in Haiti?
Keep it short and to the point. 1.20e+05. What is the difference between the highest and the lowest Aid flow (current US$) of Philippines?
Your answer should be compact. 2.55e+06. 